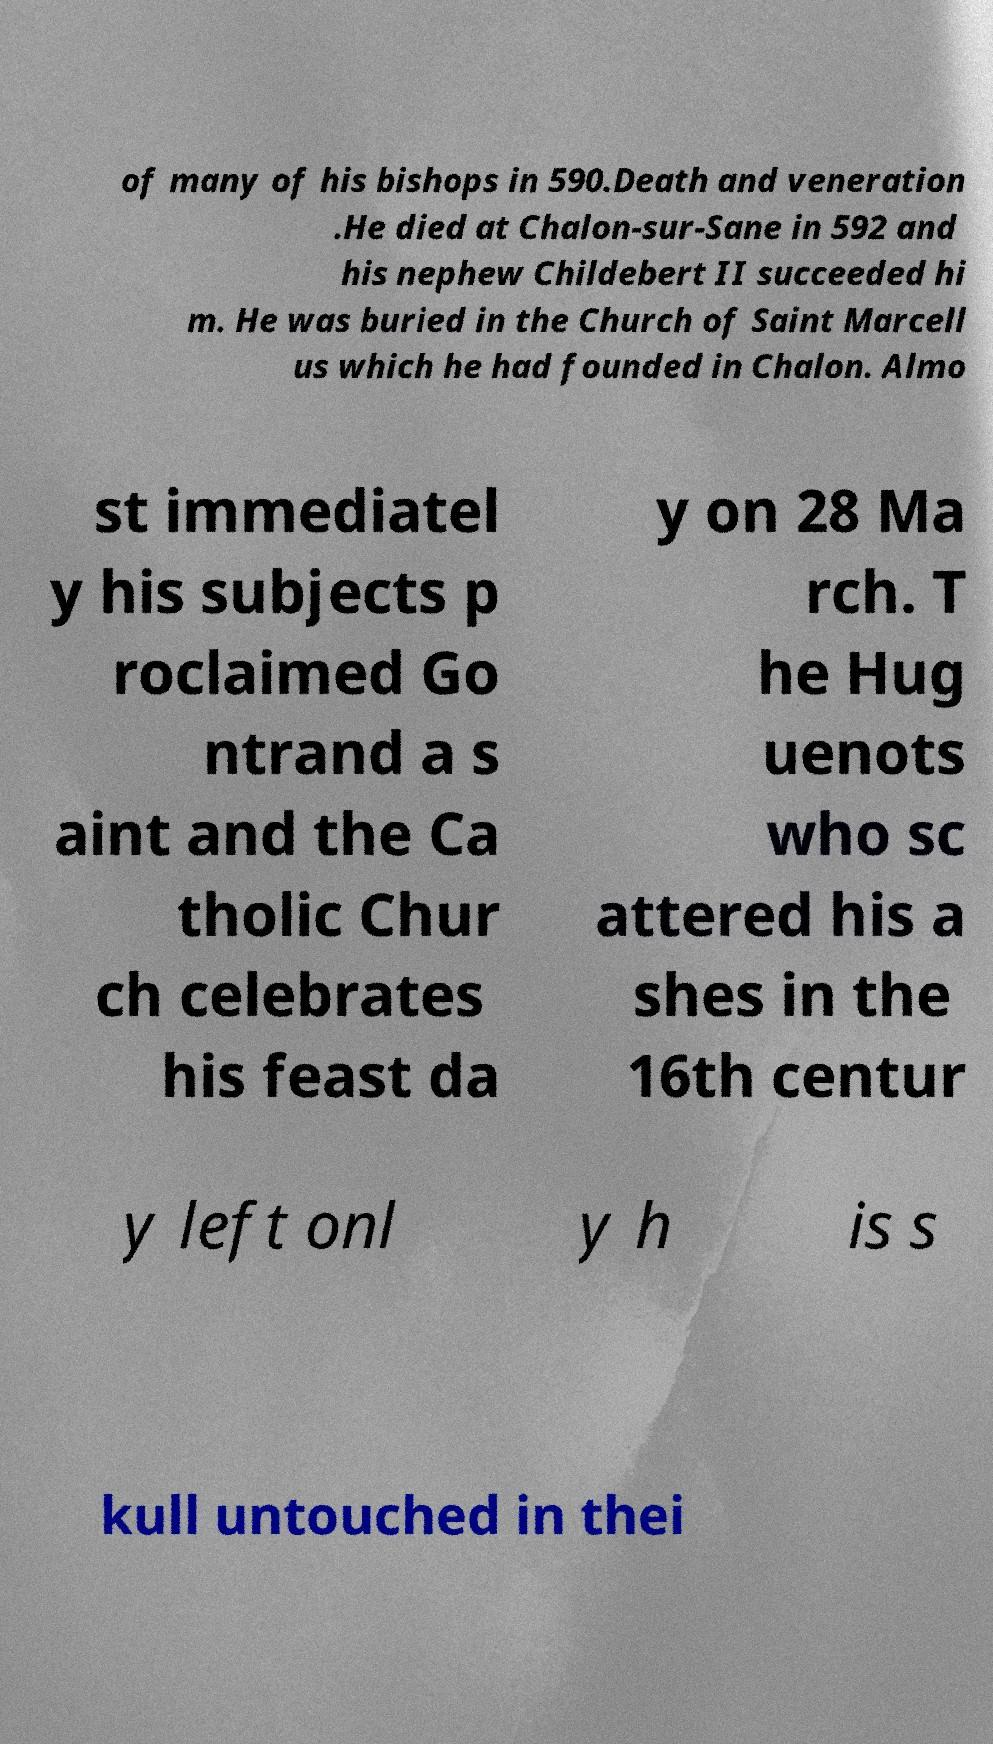Please read and relay the text visible in this image. What does it say? of many of his bishops in 590.Death and veneration .He died at Chalon-sur-Sane in 592 and his nephew Childebert II succeeded hi m. He was buried in the Church of Saint Marcell us which he had founded in Chalon. Almo st immediatel y his subjects p roclaimed Go ntrand a s aint and the Ca tholic Chur ch celebrates his feast da y on 28 Ma rch. T he Hug uenots who sc attered his a shes in the 16th centur y left onl y h is s kull untouched in thei 